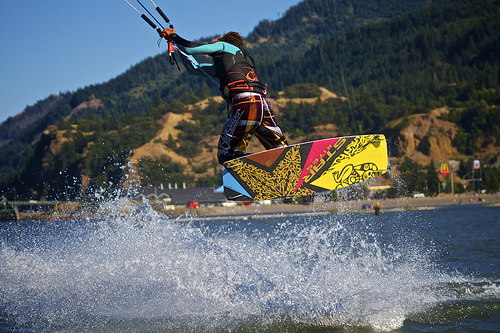<image>
Is there a man in front of the mountain? Yes. The man is positioned in front of the mountain, appearing closer to the camera viewpoint. 